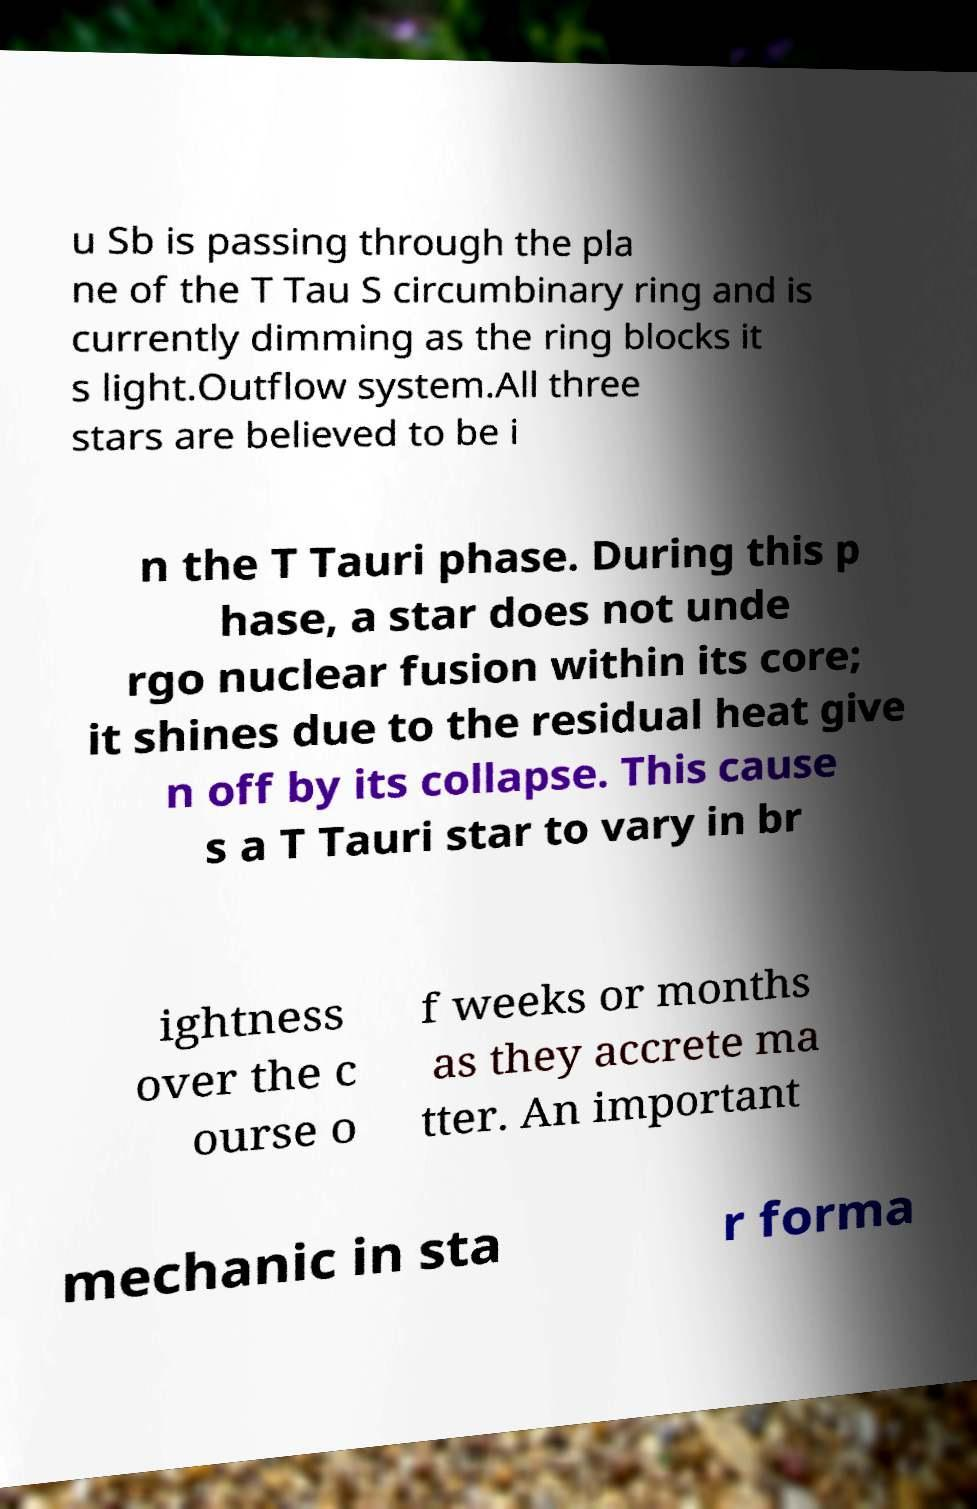Can you read and provide the text displayed in the image?This photo seems to have some interesting text. Can you extract and type it out for me? u Sb is passing through the pla ne of the T Tau S circumbinary ring and is currently dimming as the ring blocks it s light.Outflow system.All three stars are believed to be i n the T Tauri phase. During this p hase, a star does not unde rgo nuclear fusion within its core; it shines due to the residual heat give n off by its collapse. This cause s a T Tauri star to vary in br ightness over the c ourse o f weeks or months as they accrete ma tter. An important mechanic in sta r forma 